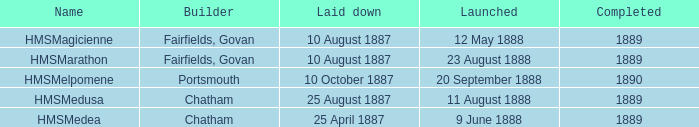When did chatham complete the Hmsmedusa? 1889.0. 